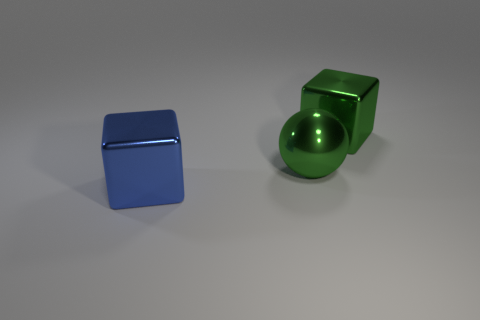Does the metal thing right of the large sphere have the same size as the metal block that is in front of the large green metal ball?
Your response must be concise. Yes. There is another object that is the same shape as the large blue object; what is its material?
Make the answer very short. Metal. What number of big things are green metal cubes or blue matte blocks?
Give a very brief answer. 1. What material is the green block?
Your answer should be compact. Metal. The object that is both in front of the green cube and right of the big blue metal thing is made of what material?
Your answer should be compact. Metal. Is the color of the metallic sphere the same as the large cube that is on the right side of the blue block?
Ensure brevity in your answer.  Yes. What material is the green cube that is the same size as the blue cube?
Your response must be concise. Metal. Is there a large red block made of the same material as the large blue cube?
Offer a terse response. No. What number of green blocks are there?
Give a very brief answer. 1. Do the large blue cube and the green cube that is behind the big shiny ball have the same material?
Ensure brevity in your answer.  Yes. 